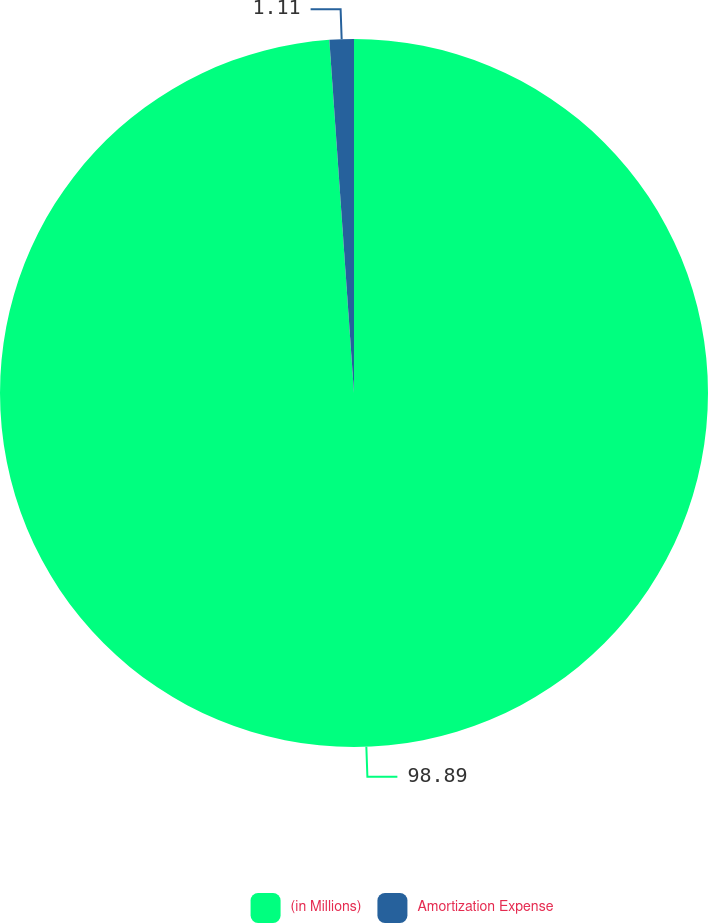Convert chart. <chart><loc_0><loc_0><loc_500><loc_500><pie_chart><fcel>(in Millions)<fcel>Amortization Expense<nl><fcel>98.89%<fcel>1.11%<nl></chart> 